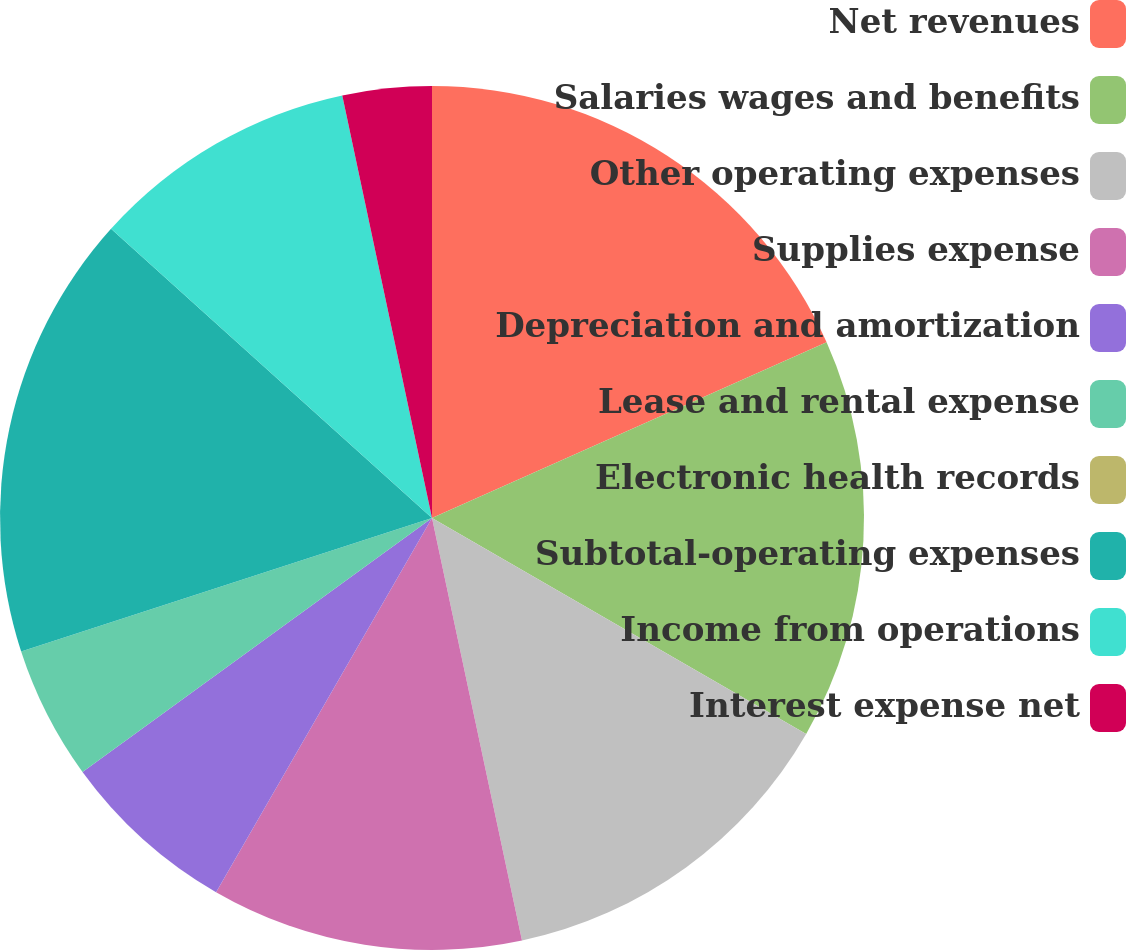Convert chart to OTSL. <chart><loc_0><loc_0><loc_500><loc_500><pie_chart><fcel>Net revenues<fcel>Salaries wages and benefits<fcel>Other operating expenses<fcel>Supplies expense<fcel>Depreciation and amortization<fcel>Lease and rental expense<fcel>Electronic health records<fcel>Subtotal-operating expenses<fcel>Income from operations<fcel>Interest expense net<nl><fcel>18.33%<fcel>15.0%<fcel>13.33%<fcel>11.67%<fcel>6.67%<fcel>5.0%<fcel>0.0%<fcel>16.67%<fcel>10.0%<fcel>3.33%<nl></chart> 